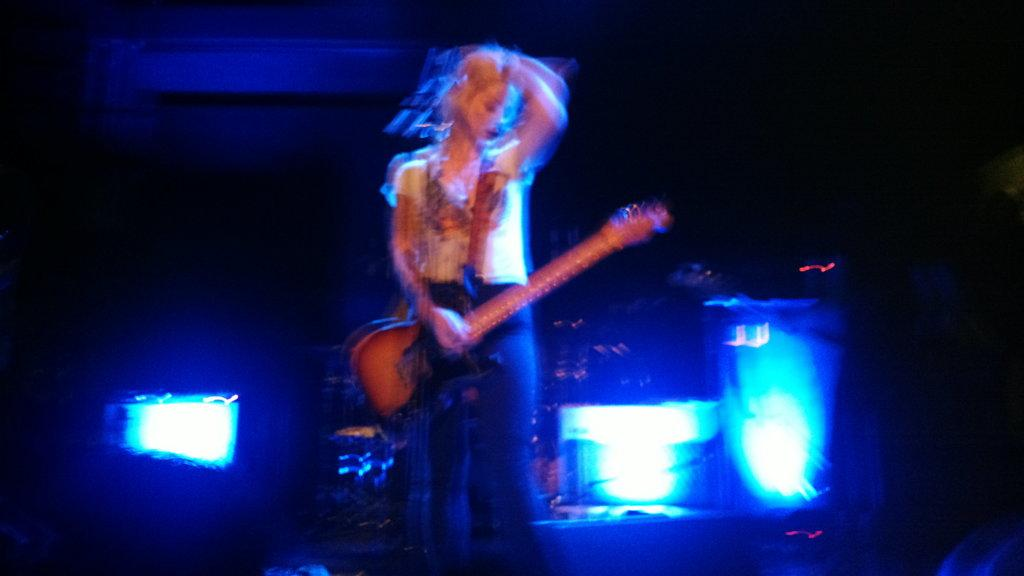Who is the main subject in the image? There is a woman in the image. What is the woman holding in the image? The woman is holding a guitar. What can be seen in the background of the image? There are lights in the background of the image. What type of rifle is the woman using to attack in the image? There is no rifle or attack present in the image; the woman is holding a guitar. 